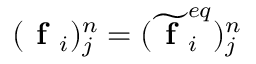Convert formula to latex. <formula><loc_0><loc_0><loc_500><loc_500>( f _ { i } ) _ { j } ^ { n } = ( \widetilde { f } _ { i } ^ { e q } ) _ { j } ^ { n }</formula> 